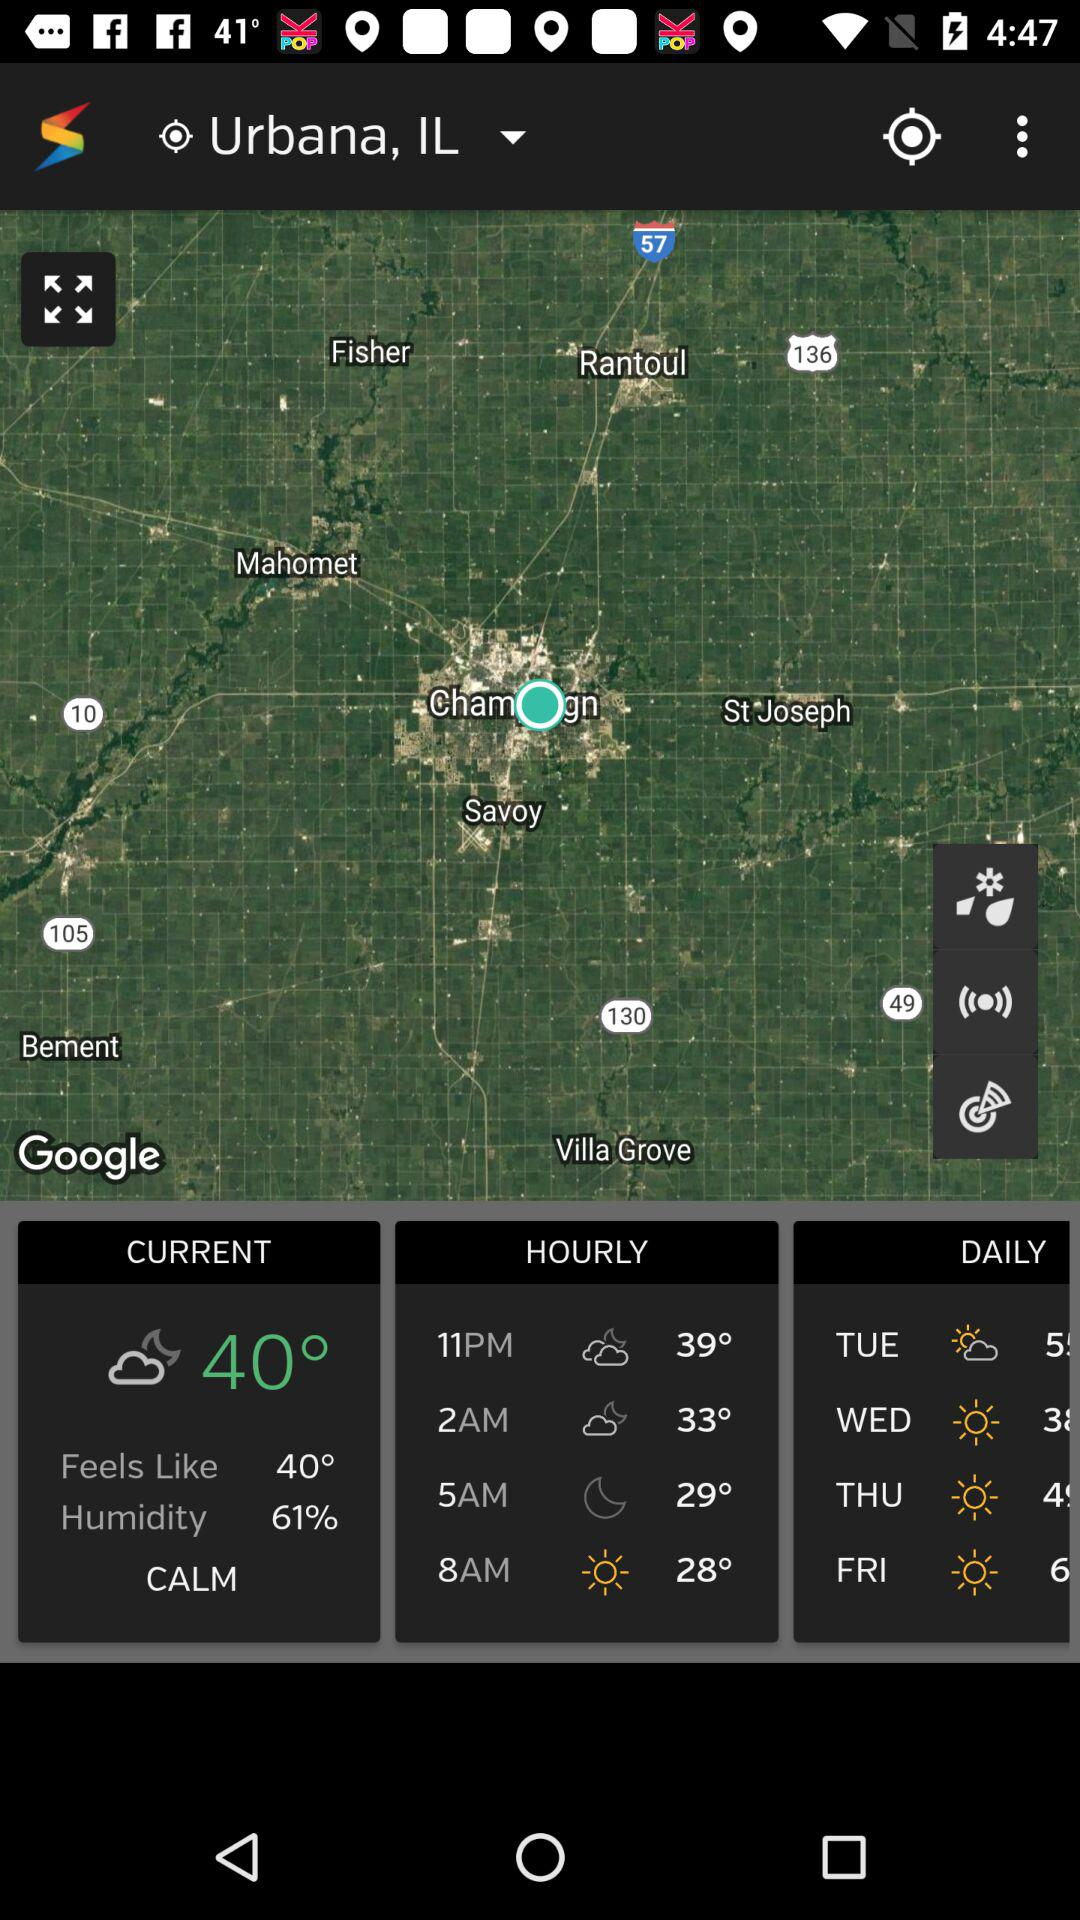What is the humidity percentage? The humidity percentage is 61. 